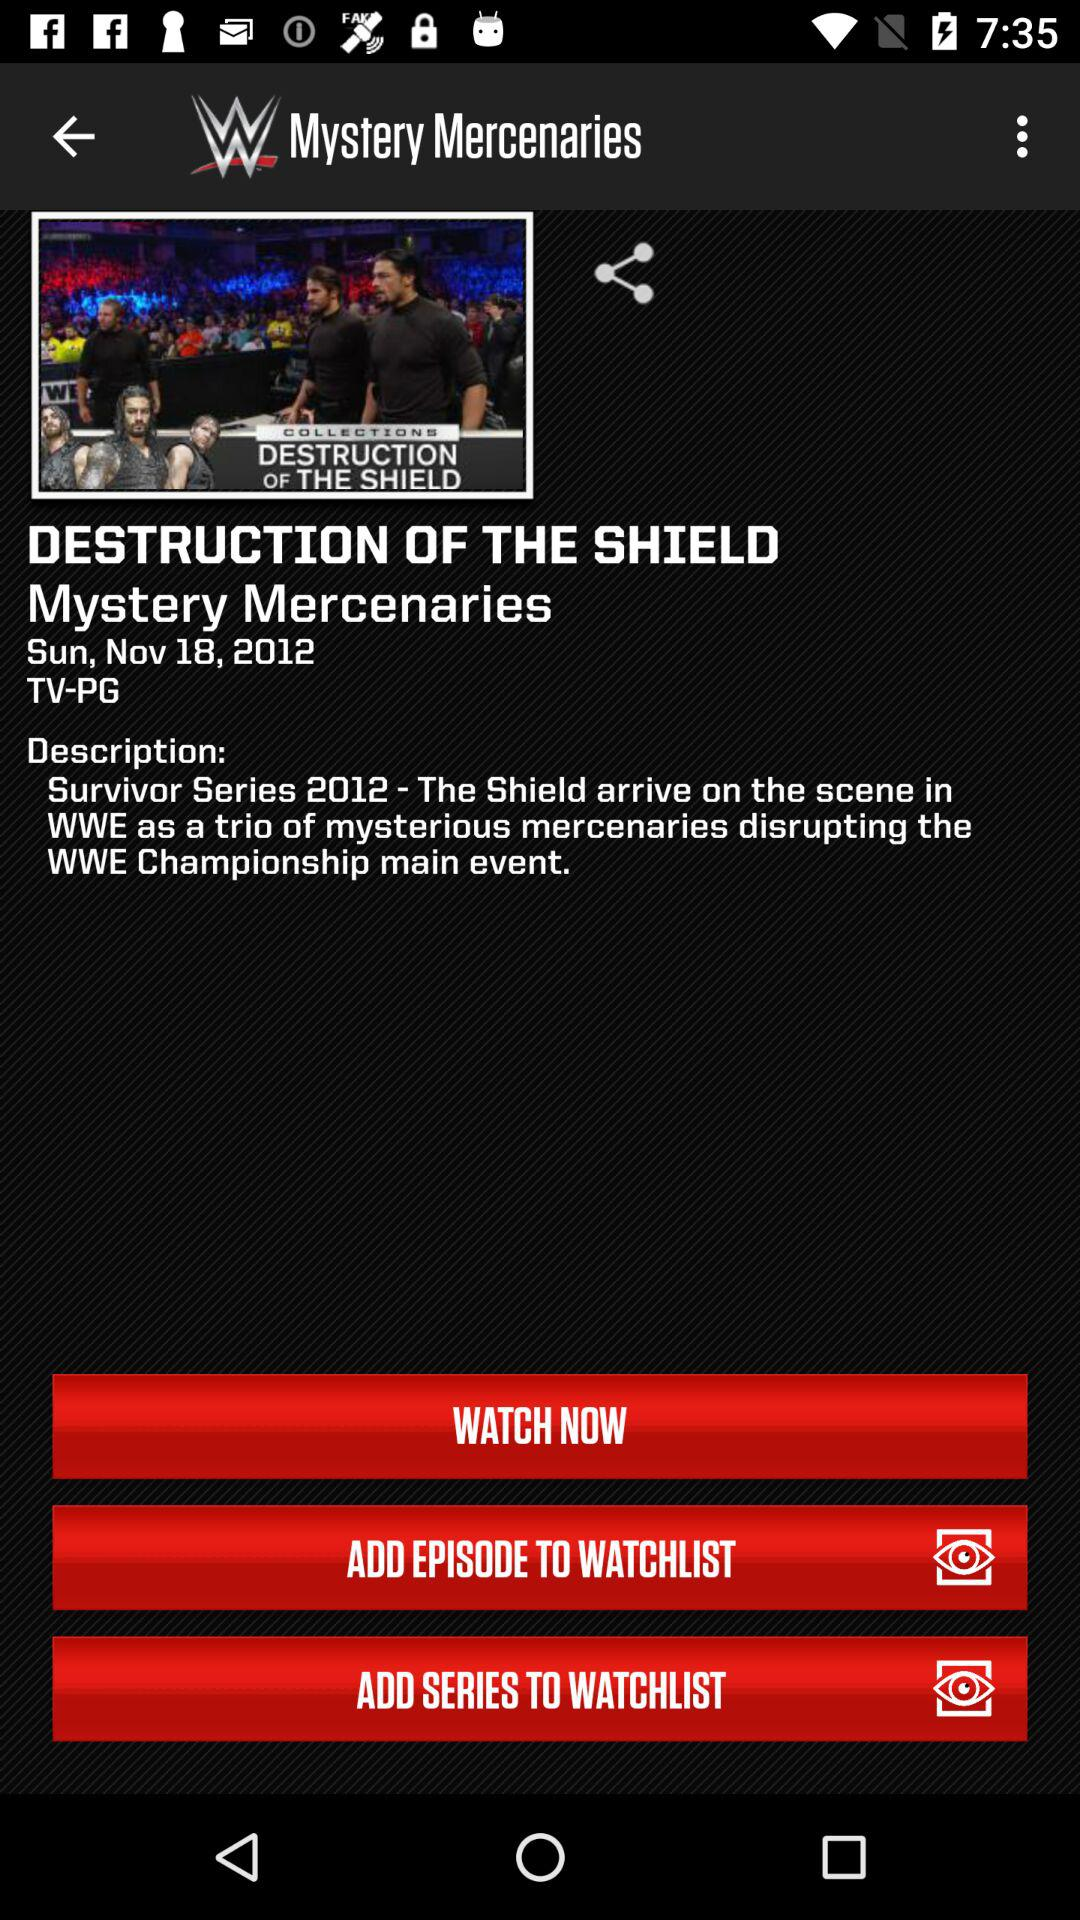What is the title of the episode? The title of the episode is "DESTRUCTION OF THE SHIELD". 